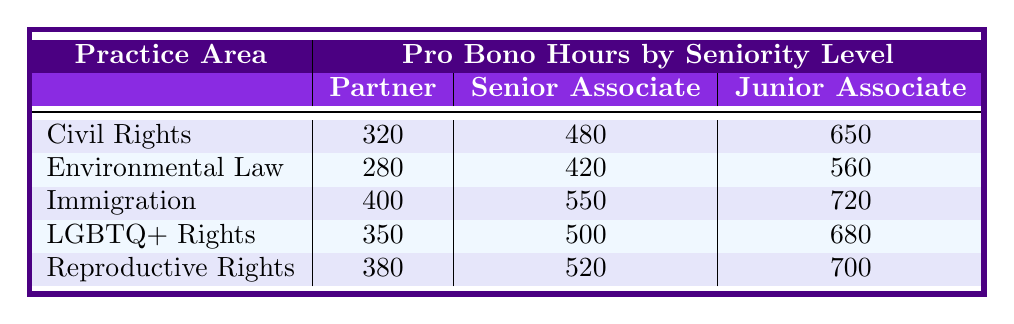What's the total number of pro bono hours contributed by Junior Associates in Environmental Law? The Junior Associate hours for Environmental Law are 560. There is only one entry for this category.
Answer: 560 Which practice area has the highest number of pro bono hours contributed by Partners? The hours from Partners for each practice area are: Civil Rights (320), Environmental Law (280), Immigration (400), LGBTQ+ Rights (350), and Reproductive Rights (380). The highest is Immigration with 400 hours.
Answer: Immigration What's the difference in pro bono hours contributed by Senior Associates between Civil Rights and LGBTQ+ Rights? Civil Rights has 480 hours contributed by Senior Associates, while LGBTQ+ Rights has 500. The difference is 500 - 480 = 20 hours.
Answer: 20 Are there more pro bono hours contributed by Junior Associates in Immigration than in Civil Rights? Junior Associates contributed 720 hours in Immigration and 650 hours in Civil Rights. Since 720 is greater than 650, the answer is yes.
Answer: Yes What is the total sum of all pro bono hours contributed by Partners across all practice areas? Adding the hours: 320 (Civil Rights) + 280 (Environmental Law) + 400 (Immigration) + 350 (LGBTQ+ Rights) + 380 (Reproductive Rights) = 1720 hours.
Answer: 1720 What is the average number of pro bono hours contributed by Senior Associates across all practice areas? Summing the hours contributed by Senior Associates gives 480 (Civil Rights) + 420 (Environmental Law) + 550 (Immigration) + 500 (LGBTQ+ Rights) + 520 (Reproductive Rights) = 2470 hours. With 5 areas, the average is 2470 / 5 = 494 hours.
Answer: 494 Which seniority level contributed the least total pro bono hours across all practice areas? Calculating the total for each level: Partners: 320 + 280 + 400 + 350 + 380 = 1720; Senior Associates: 480 + 420 + 550 + 500 + 520 = 2470; Junior Associates: 650 + 560 + 720 + 680 + 700 = 3390; The least is Partners at 1720 hours.
Answer: Partners What is the combined pro bono hours of Junior Associates in both Immigration and Reproductive Rights? Junior Associates contributed 720 hours in Immigration and 700 hours in Reproductive Rights. The combined total is 720 + 700 = 1420 hours.
Answer: 1420 Does the pro bono contribution by Senior Associates in Environmental Law exceed that of Partners in the same field? Senior Associates contributed 420 hours in Environmental Law, while Partners contributed 280 hours. Since 420 is greater than 280, the answer is yes.
Answer: Yes Which practice area shows the most significant increase in pro bono hours from Partners to Junior Associates? Calculating the differences: Civil Rights (650 - 320 = 330), Environmental Law (560 - 280 = 280), Immigration (720 - 400 = 320), LGBTQ+ Rights (680 - 350 = 330), Reproductive Rights (700 - 380 = 320); The greatest increase is seen in Civil Rights and LGBTQ+ Rights, both with 330 hours.
Answer: Civil Rights and LGBTQ+ Rights 